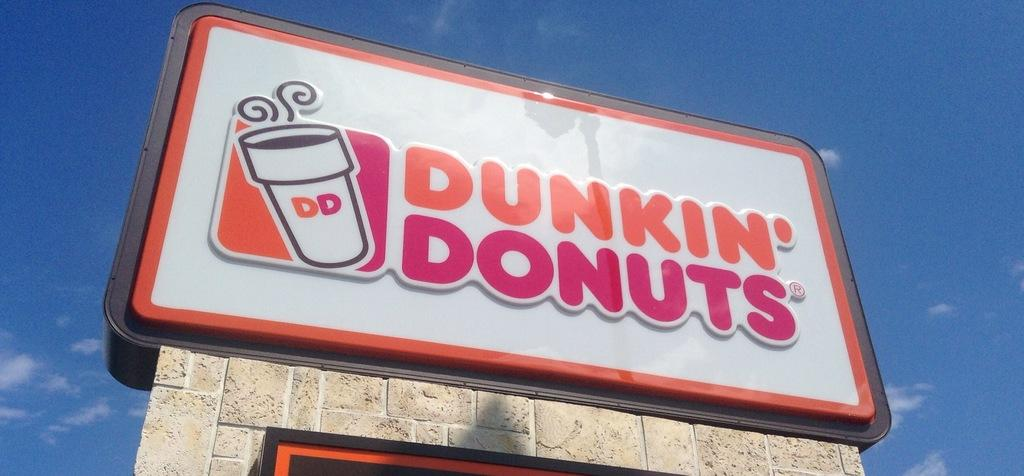<image>
Describe the image concisely. A yellow and pink Dunkin' Donuts sign rises towards the blue sky. 